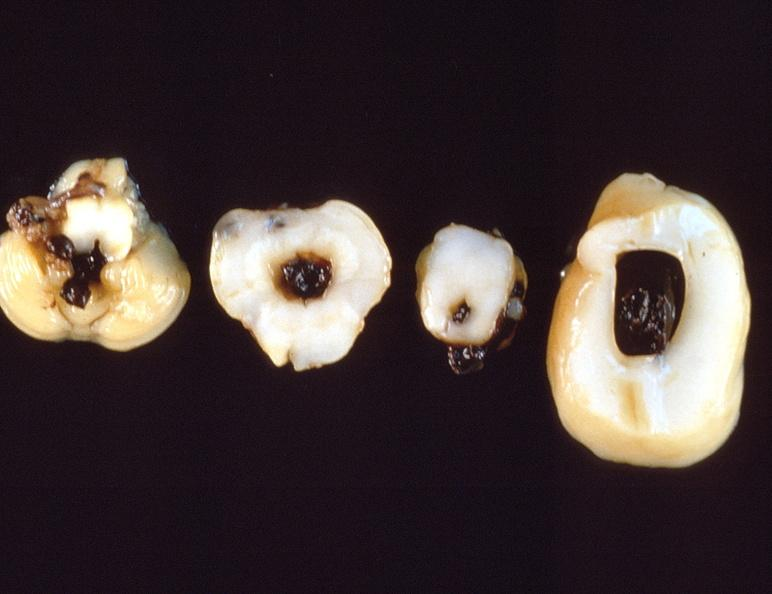what does this image show?
Answer the question using a single word or phrase. Intraventricular hemorrhage 